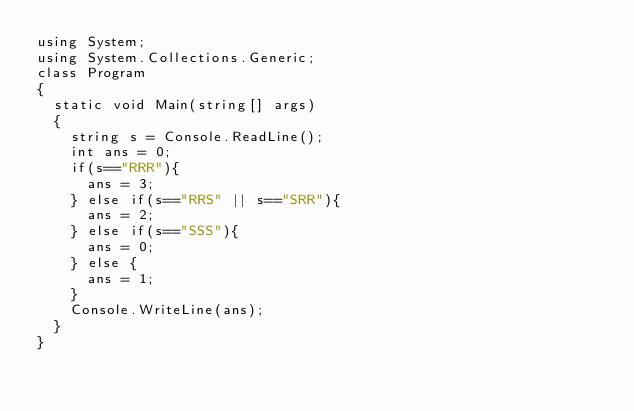Convert code to text. <code><loc_0><loc_0><loc_500><loc_500><_C#_>using System;
using System.Collections.Generic;
class Program
{
	static void Main(string[] args)
	{
		string s = Console.ReadLine();
		int ans = 0;
		if(s=="RRR"){
			ans = 3;
		} else if(s=="RRS" || s=="SRR"){
			ans = 2;
		} else if(s=="SSS"){
			ans = 0;
		} else {
			ans = 1;
		}
		Console.WriteLine(ans);
	}
}</code> 